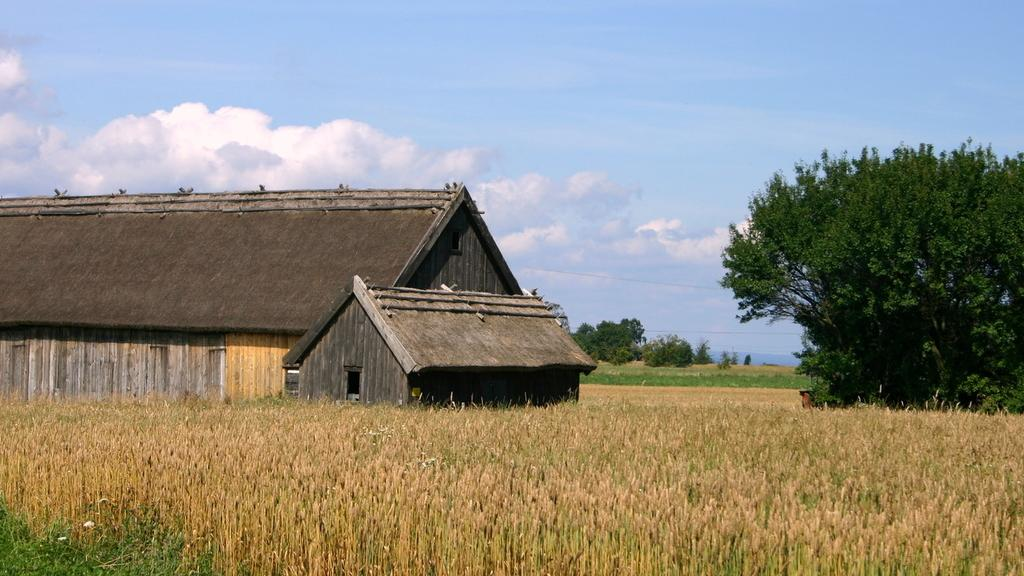What is the main structure in the center of the image? There is a house in the center of the image. What type of vegetation can be seen at the bottom of the image? There are crops at the bottom of the image. What natural element is located at the right side of the image? There is a tree at the right side of the image. What is visible at the top of the image? The sky is visible at the top of the image. Can you hear the sound of planes flying in the image? There is no sound present in the image, and no planes are visible. How does the tree laugh in the image? Trees do not have the ability to laugh, and there is no laughter present in the image. 